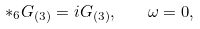Convert formula to latex. <formula><loc_0><loc_0><loc_500><loc_500>\ast _ { 6 } G _ { ( 3 ) } = i G _ { ( 3 ) } , \quad \omega = 0 ,</formula> 